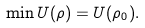Convert formula to latex. <formula><loc_0><loc_0><loc_500><loc_500>\min U ( \rho ) = U ( \rho _ { 0 } ) .</formula> 